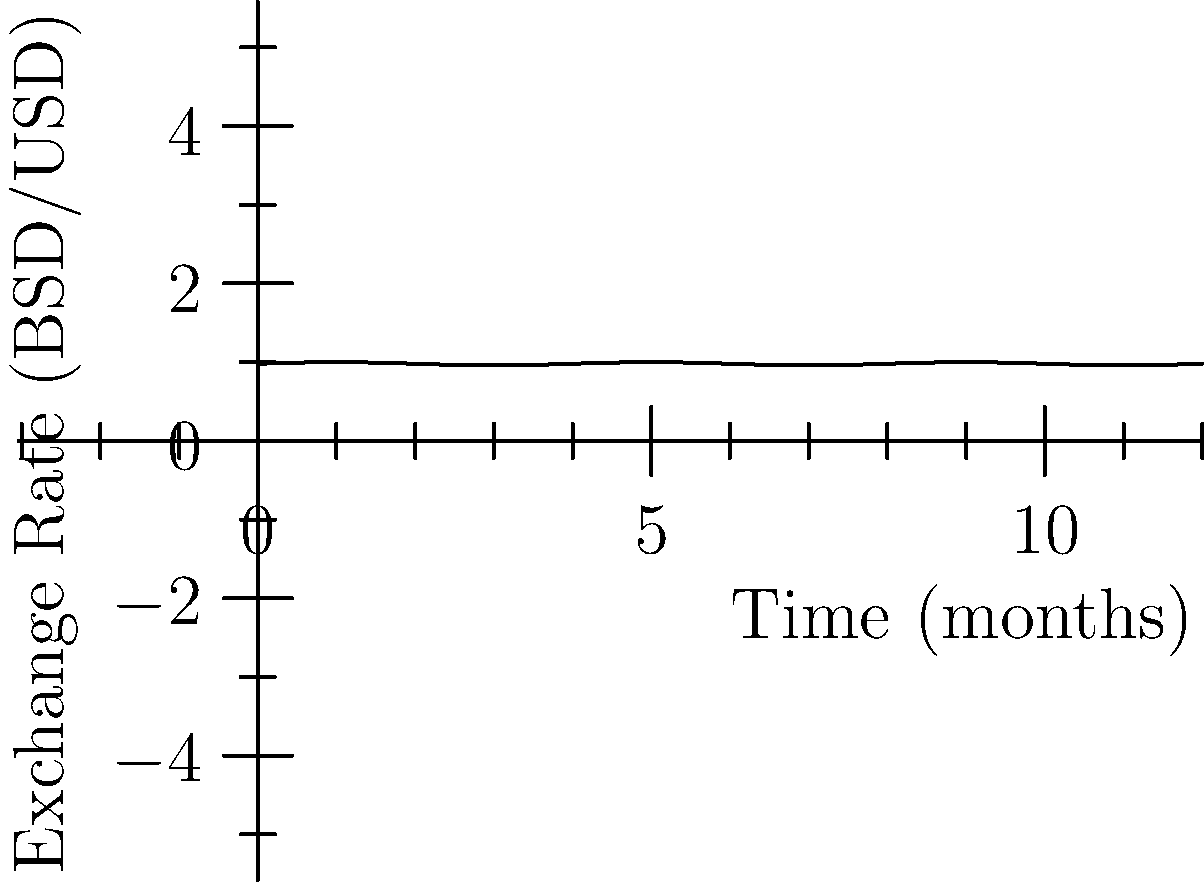The graph shows the exchange rate between Bahamian dollars (BSD) and US dollars (USD) over a 12-month period. If you exchanged $1000 USD at the highest rate and $1000 USD at the lowest rate during this period, what is the difference in BSD received between these two exchanges? To solve this problem, we need to follow these steps:

1. Identify the highest and lowest exchange rates from the graph:
   Highest rate: 1 USD = 1.00 BSD
   Lowest rate: 1 USD = 0.96 BSD

2. Calculate the BSD received at the highest rate:
   $1000 \times 1.00 = 1000$ BSD

3. Calculate the BSD received at the lowest rate:
   $1000 \times 0.96 = 960$ BSD

4. Find the difference between the two amounts:
   $1000 - 960 = 40$ BSD

Therefore, the difference in BSD received between the two exchanges is 40 BSD.
Answer: 40 BSD 